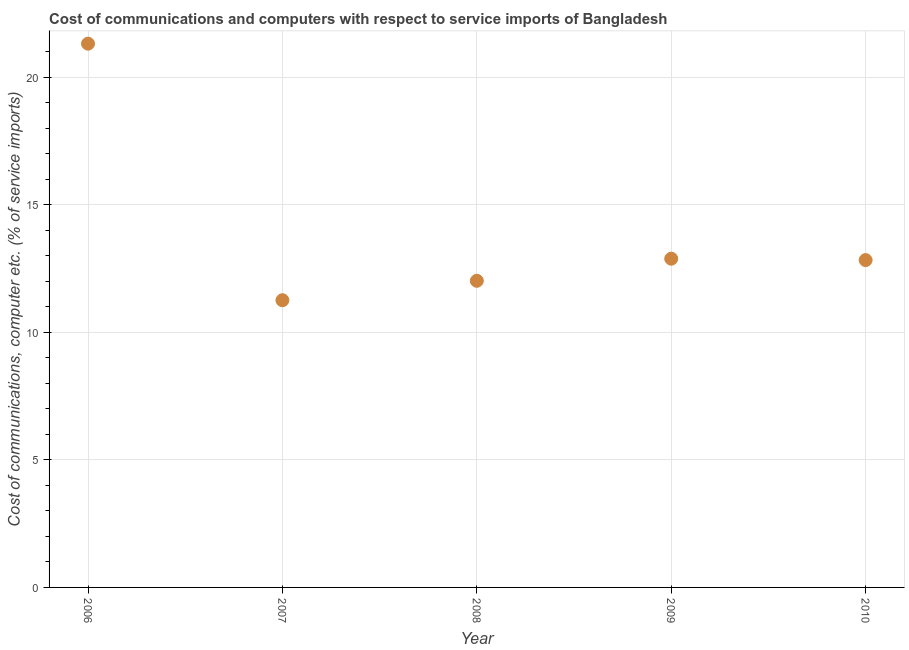What is the cost of communications and computer in 2006?
Your answer should be compact. 21.31. Across all years, what is the maximum cost of communications and computer?
Your answer should be compact. 21.31. Across all years, what is the minimum cost of communications and computer?
Offer a terse response. 11.26. In which year was the cost of communications and computer minimum?
Offer a very short reply. 2007. What is the sum of the cost of communications and computer?
Your answer should be very brief. 70.3. What is the difference between the cost of communications and computer in 2007 and 2010?
Ensure brevity in your answer.  -1.57. What is the average cost of communications and computer per year?
Offer a very short reply. 14.06. What is the median cost of communications and computer?
Your answer should be compact. 12.83. What is the ratio of the cost of communications and computer in 2006 to that in 2007?
Keep it short and to the point. 1.89. What is the difference between the highest and the second highest cost of communications and computer?
Offer a terse response. 8.43. What is the difference between the highest and the lowest cost of communications and computer?
Your response must be concise. 10.06. How many years are there in the graph?
Your response must be concise. 5. What is the difference between two consecutive major ticks on the Y-axis?
Offer a terse response. 5. Does the graph contain any zero values?
Make the answer very short. No. What is the title of the graph?
Your answer should be compact. Cost of communications and computers with respect to service imports of Bangladesh. What is the label or title of the Y-axis?
Your answer should be compact. Cost of communications, computer etc. (% of service imports). What is the Cost of communications, computer etc. (% of service imports) in 2006?
Your answer should be compact. 21.31. What is the Cost of communications, computer etc. (% of service imports) in 2007?
Offer a very short reply. 11.26. What is the Cost of communications, computer etc. (% of service imports) in 2008?
Keep it short and to the point. 12.02. What is the Cost of communications, computer etc. (% of service imports) in 2009?
Give a very brief answer. 12.88. What is the Cost of communications, computer etc. (% of service imports) in 2010?
Offer a very short reply. 12.83. What is the difference between the Cost of communications, computer etc. (% of service imports) in 2006 and 2007?
Ensure brevity in your answer.  10.06. What is the difference between the Cost of communications, computer etc. (% of service imports) in 2006 and 2008?
Your answer should be very brief. 9.29. What is the difference between the Cost of communications, computer etc. (% of service imports) in 2006 and 2009?
Your response must be concise. 8.43. What is the difference between the Cost of communications, computer etc. (% of service imports) in 2006 and 2010?
Provide a short and direct response. 8.48. What is the difference between the Cost of communications, computer etc. (% of service imports) in 2007 and 2008?
Offer a very short reply. -0.76. What is the difference between the Cost of communications, computer etc. (% of service imports) in 2007 and 2009?
Keep it short and to the point. -1.63. What is the difference between the Cost of communications, computer etc. (% of service imports) in 2007 and 2010?
Ensure brevity in your answer.  -1.57. What is the difference between the Cost of communications, computer etc. (% of service imports) in 2008 and 2009?
Make the answer very short. -0.87. What is the difference between the Cost of communications, computer etc. (% of service imports) in 2008 and 2010?
Your answer should be compact. -0.81. What is the difference between the Cost of communications, computer etc. (% of service imports) in 2009 and 2010?
Your response must be concise. 0.06. What is the ratio of the Cost of communications, computer etc. (% of service imports) in 2006 to that in 2007?
Provide a short and direct response. 1.89. What is the ratio of the Cost of communications, computer etc. (% of service imports) in 2006 to that in 2008?
Keep it short and to the point. 1.77. What is the ratio of the Cost of communications, computer etc. (% of service imports) in 2006 to that in 2009?
Give a very brief answer. 1.65. What is the ratio of the Cost of communications, computer etc. (% of service imports) in 2006 to that in 2010?
Keep it short and to the point. 1.66. What is the ratio of the Cost of communications, computer etc. (% of service imports) in 2007 to that in 2008?
Provide a succinct answer. 0.94. What is the ratio of the Cost of communications, computer etc. (% of service imports) in 2007 to that in 2009?
Your answer should be very brief. 0.87. What is the ratio of the Cost of communications, computer etc. (% of service imports) in 2007 to that in 2010?
Your response must be concise. 0.88. What is the ratio of the Cost of communications, computer etc. (% of service imports) in 2008 to that in 2009?
Ensure brevity in your answer.  0.93. What is the ratio of the Cost of communications, computer etc. (% of service imports) in 2008 to that in 2010?
Keep it short and to the point. 0.94. What is the ratio of the Cost of communications, computer etc. (% of service imports) in 2009 to that in 2010?
Provide a short and direct response. 1. 